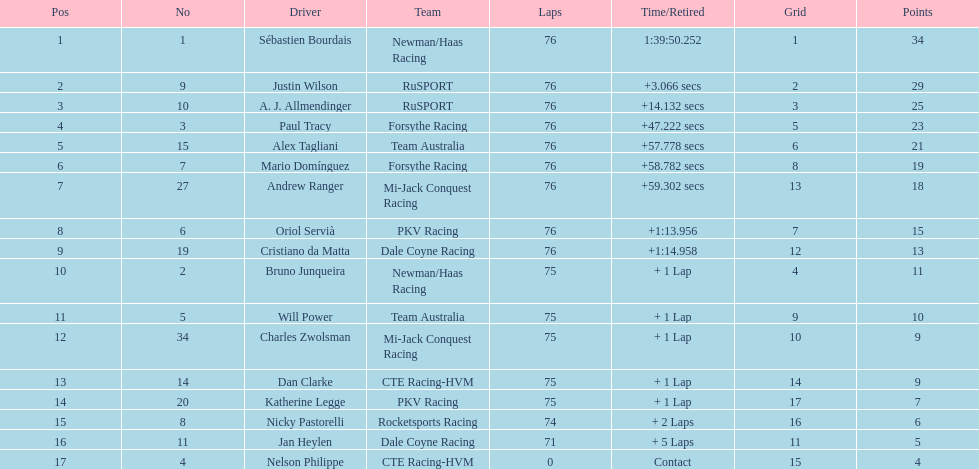Give me the full table as a dictionary. {'header': ['Pos', 'No', 'Driver', 'Team', 'Laps', 'Time/Retired', 'Grid', 'Points'], 'rows': [['1', '1', 'Sébastien Bourdais', 'Newman/Haas Racing', '76', '1:39:50.252', '1', '34'], ['2', '9', 'Justin Wilson', 'RuSPORT', '76', '+3.066 secs', '2', '29'], ['3', '10', 'A. J. Allmendinger', 'RuSPORT', '76', '+14.132 secs', '3', '25'], ['4', '3', 'Paul Tracy', 'Forsythe Racing', '76', '+47.222 secs', '5', '23'], ['5', '15', 'Alex Tagliani', 'Team Australia', '76', '+57.778 secs', '6', '21'], ['6', '7', 'Mario Domínguez', 'Forsythe Racing', '76', '+58.782 secs', '8', '19'], ['7', '27', 'Andrew Ranger', 'Mi-Jack Conquest Racing', '76', '+59.302 secs', '13', '18'], ['8', '6', 'Oriol Servià', 'PKV Racing', '76', '+1:13.956', '7', '15'], ['9', '19', 'Cristiano da Matta', 'Dale Coyne Racing', '76', '+1:14.958', '12', '13'], ['10', '2', 'Bruno Junqueira', 'Newman/Haas Racing', '75', '+ 1 Lap', '4', '11'], ['11', '5', 'Will Power', 'Team Australia', '75', '+ 1 Lap', '9', '10'], ['12', '34', 'Charles Zwolsman', 'Mi-Jack Conquest Racing', '75', '+ 1 Lap', '10', '9'], ['13', '14', 'Dan Clarke', 'CTE Racing-HVM', '75', '+ 1 Lap', '14', '9'], ['14', '20', 'Katherine Legge', 'PKV Racing', '75', '+ 1 Lap', '17', '7'], ['15', '8', 'Nicky Pastorelli', 'Rocketsports Racing', '74', '+ 2 Laps', '16', '6'], ['16', '11', 'Jan Heylen', 'Dale Coyne Racing', '71', '+ 5 Laps', '11', '5'], ['17', '4', 'Nelson Philippe', 'CTE Racing-HVM', '0', 'Contact', '15', '4']]} Which canadian racer came in first: alex tagliani or paul tracy? Paul Tracy. 